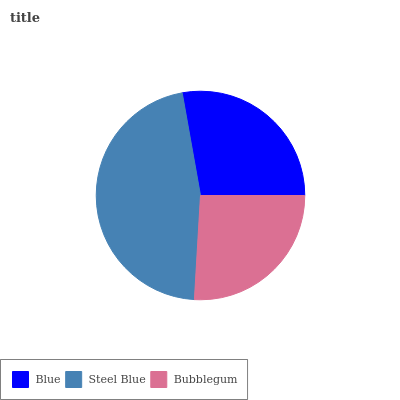Is Bubblegum the minimum?
Answer yes or no. Yes. Is Steel Blue the maximum?
Answer yes or no. Yes. Is Steel Blue the minimum?
Answer yes or no. No. Is Bubblegum the maximum?
Answer yes or no. No. Is Steel Blue greater than Bubblegum?
Answer yes or no. Yes. Is Bubblegum less than Steel Blue?
Answer yes or no. Yes. Is Bubblegum greater than Steel Blue?
Answer yes or no. No. Is Steel Blue less than Bubblegum?
Answer yes or no. No. Is Blue the high median?
Answer yes or no. Yes. Is Blue the low median?
Answer yes or no. Yes. Is Bubblegum the high median?
Answer yes or no. No. Is Bubblegum the low median?
Answer yes or no. No. 